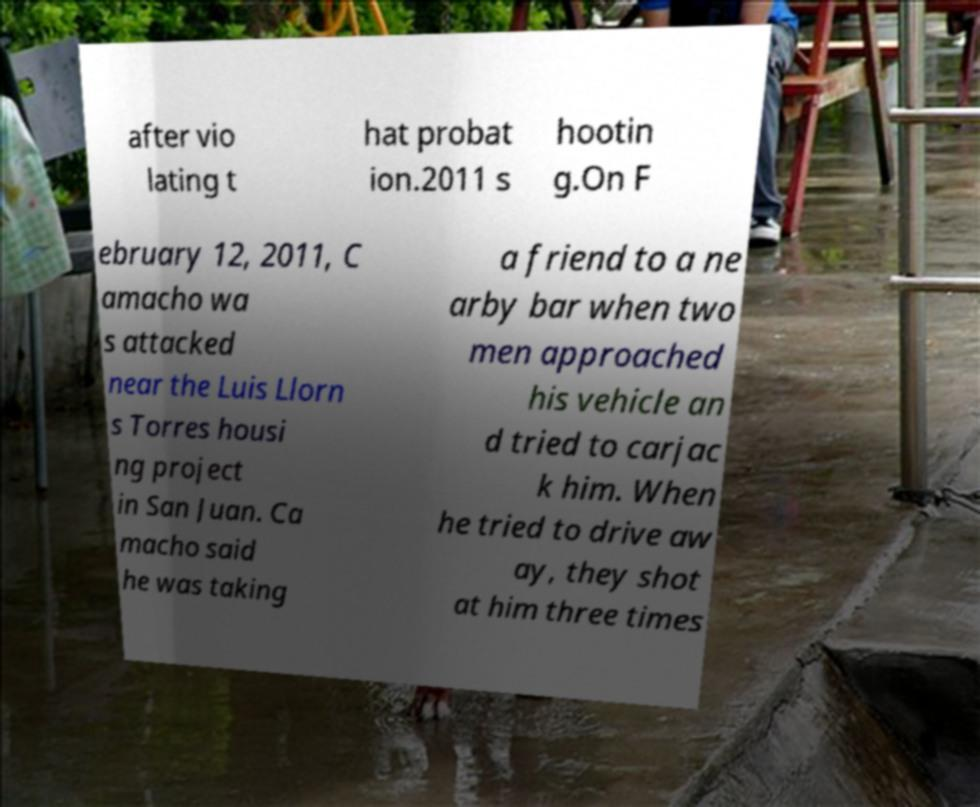What messages or text are displayed in this image? I need them in a readable, typed format. after vio lating t hat probat ion.2011 s hootin g.On F ebruary 12, 2011, C amacho wa s attacked near the Luis Llorn s Torres housi ng project in San Juan. Ca macho said he was taking a friend to a ne arby bar when two men approached his vehicle an d tried to carjac k him. When he tried to drive aw ay, they shot at him three times 